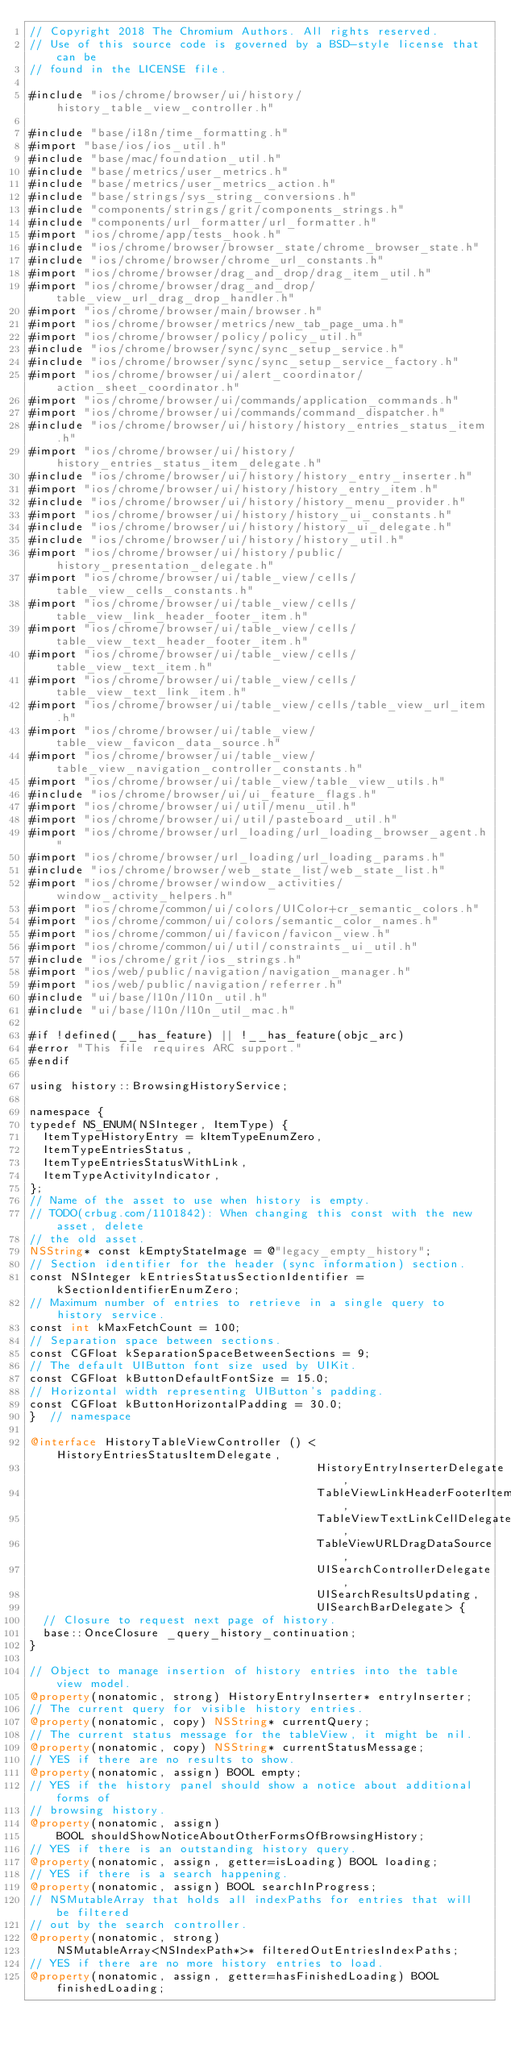Convert code to text. <code><loc_0><loc_0><loc_500><loc_500><_ObjectiveC_>// Copyright 2018 The Chromium Authors. All rights reserved.
// Use of this source code is governed by a BSD-style license that can be
// found in the LICENSE file.

#include "ios/chrome/browser/ui/history/history_table_view_controller.h"

#include "base/i18n/time_formatting.h"
#import "base/ios/ios_util.h"
#include "base/mac/foundation_util.h"
#include "base/metrics/user_metrics.h"
#include "base/metrics/user_metrics_action.h"
#include "base/strings/sys_string_conversions.h"
#include "components/strings/grit/components_strings.h"
#include "components/url_formatter/url_formatter.h"
#import "ios/chrome/app/tests_hook.h"
#include "ios/chrome/browser/browser_state/chrome_browser_state.h"
#include "ios/chrome/browser/chrome_url_constants.h"
#import "ios/chrome/browser/drag_and_drop/drag_item_util.h"
#import "ios/chrome/browser/drag_and_drop/table_view_url_drag_drop_handler.h"
#import "ios/chrome/browser/main/browser.h"
#import "ios/chrome/browser/metrics/new_tab_page_uma.h"
#import "ios/chrome/browser/policy/policy_util.h"
#include "ios/chrome/browser/sync/sync_setup_service.h"
#include "ios/chrome/browser/sync/sync_setup_service_factory.h"
#import "ios/chrome/browser/ui/alert_coordinator/action_sheet_coordinator.h"
#import "ios/chrome/browser/ui/commands/application_commands.h"
#import "ios/chrome/browser/ui/commands/command_dispatcher.h"
#include "ios/chrome/browser/ui/history/history_entries_status_item.h"
#import "ios/chrome/browser/ui/history/history_entries_status_item_delegate.h"
#include "ios/chrome/browser/ui/history/history_entry_inserter.h"
#import "ios/chrome/browser/ui/history/history_entry_item.h"
#include "ios/chrome/browser/ui/history/history_menu_provider.h"
#import "ios/chrome/browser/ui/history/history_ui_constants.h"
#include "ios/chrome/browser/ui/history/history_ui_delegate.h"
#include "ios/chrome/browser/ui/history/history_util.h"
#import "ios/chrome/browser/ui/history/public/history_presentation_delegate.h"
#import "ios/chrome/browser/ui/table_view/cells/table_view_cells_constants.h"
#import "ios/chrome/browser/ui/table_view/cells/table_view_link_header_footer_item.h"
#import "ios/chrome/browser/ui/table_view/cells/table_view_text_header_footer_item.h"
#import "ios/chrome/browser/ui/table_view/cells/table_view_text_item.h"
#import "ios/chrome/browser/ui/table_view/cells/table_view_text_link_item.h"
#import "ios/chrome/browser/ui/table_view/cells/table_view_url_item.h"
#import "ios/chrome/browser/ui/table_view/table_view_favicon_data_source.h"
#import "ios/chrome/browser/ui/table_view/table_view_navigation_controller_constants.h"
#import "ios/chrome/browser/ui/table_view/table_view_utils.h"
#include "ios/chrome/browser/ui/ui_feature_flags.h"
#import "ios/chrome/browser/ui/util/menu_util.h"
#import "ios/chrome/browser/ui/util/pasteboard_util.h"
#import "ios/chrome/browser/url_loading/url_loading_browser_agent.h"
#import "ios/chrome/browser/url_loading/url_loading_params.h"
#include "ios/chrome/browser/web_state_list/web_state_list.h"
#import "ios/chrome/browser/window_activities/window_activity_helpers.h"
#import "ios/chrome/common/ui/colors/UIColor+cr_semantic_colors.h"
#import "ios/chrome/common/ui/colors/semantic_color_names.h"
#import "ios/chrome/common/ui/favicon/favicon_view.h"
#import "ios/chrome/common/ui/util/constraints_ui_util.h"
#include "ios/chrome/grit/ios_strings.h"
#import "ios/web/public/navigation/navigation_manager.h"
#import "ios/web/public/navigation/referrer.h"
#include "ui/base/l10n/l10n_util.h"
#include "ui/base/l10n/l10n_util_mac.h"

#if !defined(__has_feature) || !__has_feature(objc_arc)
#error "This file requires ARC support."
#endif

using history::BrowsingHistoryService;

namespace {
typedef NS_ENUM(NSInteger, ItemType) {
  ItemTypeHistoryEntry = kItemTypeEnumZero,
  ItemTypeEntriesStatus,
  ItemTypeEntriesStatusWithLink,
  ItemTypeActivityIndicator,
};
// Name of the asset to use when history is empty.
// TODO(crbug.com/1101842): When changing this const with the new asset, delete
// the old asset.
NSString* const kEmptyStateImage = @"legacy_empty_history";
// Section identifier for the header (sync information) section.
const NSInteger kEntriesStatusSectionIdentifier = kSectionIdentifierEnumZero;
// Maximum number of entries to retrieve in a single query to history service.
const int kMaxFetchCount = 100;
// Separation space between sections.
const CGFloat kSeparationSpaceBetweenSections = 9;
// The default UIButton font size used by UIKit.
const CGFloat kButtonDefaultFontSize = 15.0;
// Horizontal width representing UIButton's padding.
const CGFloat kButtonHorizontalPadding = 30.0;
}  // namespace

@interface HistoryTableViewController () <HistoryEntriesStatusItemDelegate,
                                          HistoryEntryInserterDelegate,
                                          TableViewLinkHeaderFooterItemDelegate,
                                          TableViewTextLinkCellDelegate,
                                          TableViewURLDragDataSource,
                                          UISearchControllerDelegate,
                                          UISearchResultsUpdating,
                                          UISearchBarDelegate> {
  // Closure to request next page of history.
  base::OnceClosure _query_history_continuation;
}

// Object to manage insertion of history entries into the table view model.
@property(nonatomic, strong) HistoryEntryInserter* entryInserter;
// The current query for visible history entries.
@property(nonatomic, copy) NSString* currentQuery;
// The current status message for the tableView, it might be nil.
@property(nonatomic, copy) NSString* currentStatusMessage;
// YES if there are no results to show.
@property(nonatomic, assign) BOOL empty;
// YES if the history panel should show a notice about additional forms of
// browsing history.
@property(nonatomic, assign)
    BOOL shouldShowNoticeAboutOtherFormsOfBrowsingHistory;
// YES if there is an outstanding history query.
@property(nonatomic, assign, getter=isLoading) BOOL loading;
// YES if there is a search happening.
@property(nonatomic, assign) BOOL searchInProgress;
// NSMutableArray that holds all indexPaths for entries that will be filtered
// out by the search controller.
@property(nonatomic, strong)
    NSMutableArray<NSIndexPath*>* filteredOutEntriesIndexPaths;
// YES if there are no more history entries to load.
@property(nonatomic, assign, getter=hasFinishedLoading) BOOL finishedLoading;</code> 